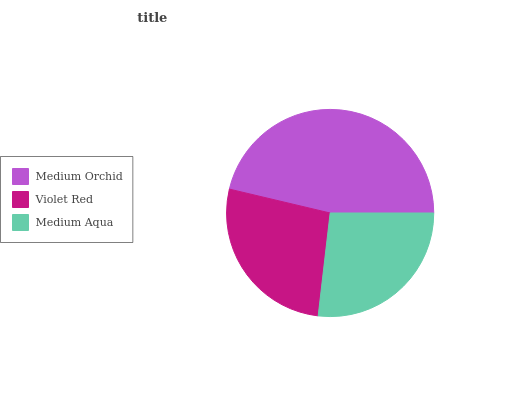Is Medium Aqua the minimum?
Answer yes or no. Yes. Is Medium Orchid the maximum?
Answer yes or no. Yes. Is Violet Red the minimum?
Answer yes or no. No. Is Violet Red the maximum?
Answer yes or no. No. Is Medium Orchid greater than Violet Red?
Answer yes or no. Yes. Is Violet Red less than Medium Orchid?
Answer yes or no. Yes. Is Violet Red greater than Medium Orchid?
Answer yes or no. No. Is Medium Orchid less than Violet Red?
Answer yes or no. No. Is Violet Red the high median?
Answer yes or no. Yes. Is Violet Red the low median?
Answer yes or no. Yes. Is Medium Orchid the high median?
Answer yes or no. No. Is Medium Aqua the low median?
Answer yes or no. No. 